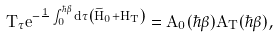Convert formula to latex. <formula><loc_0><loc_0><loc_500><loc_500>T _ { \tau } e ^ { - \frac { 1 } { } \int _ { 0 } ^ { \hbar { \beta } } d \tau \left ( \widetilde { H } _ { 0 } + H _ { T } \right ) } = A _ { 0 } ( \hbar { \beta } ) A _ { T } ( \hbar { \beta } ) ,</formula> 